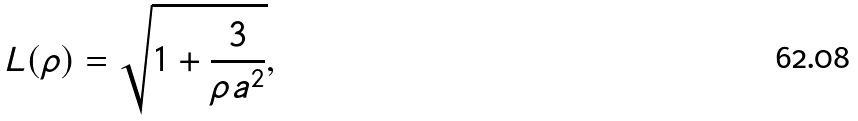Convert formula to latex. <formula><loc_0><loc_0><loc_500><loc_500>L ( \rho ) = \sqrt { 1 + \frac { 3 } { \rho a ^ { 2 } } } ,</formula> 